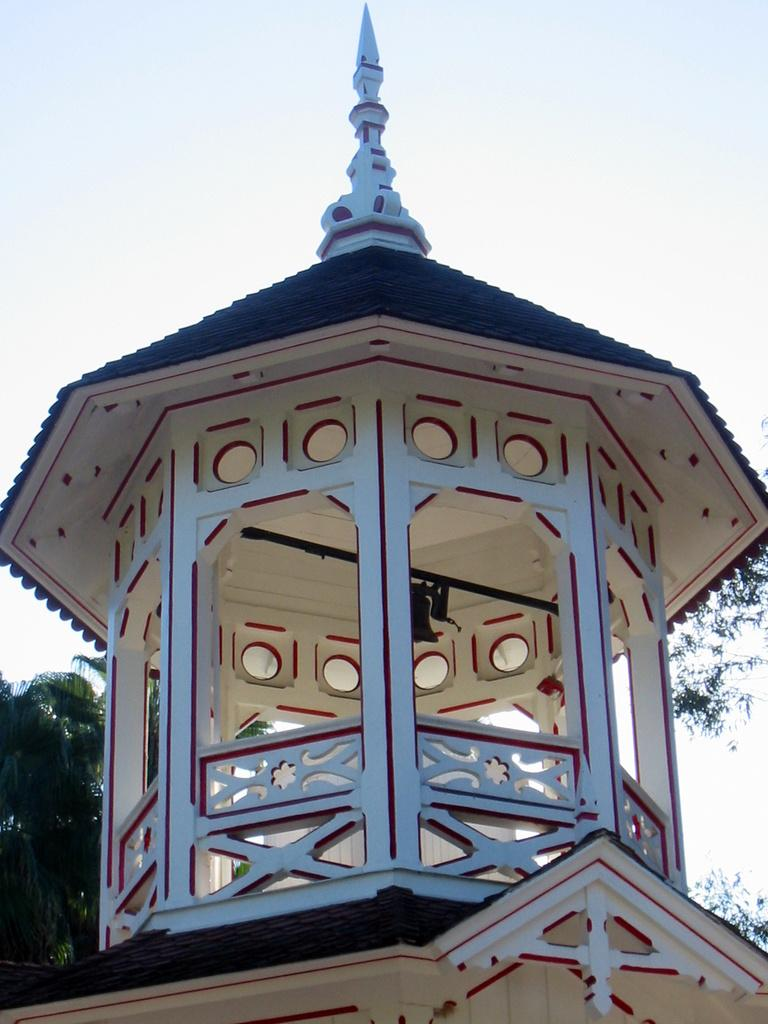What type of structure is present in the image? There is a house in the image. What object can be seen near the house? There is a bell in the image. What type of vegetation is visible in the image? There are trees in the image. What is visible in the background of the image? The sky is visible in the image. Can you hear the donkey braying in the image? There is no donkey present in the image, so it cannot be heard. How many dimes are visible on the ground in the image? There are no dimes visible in the image. 